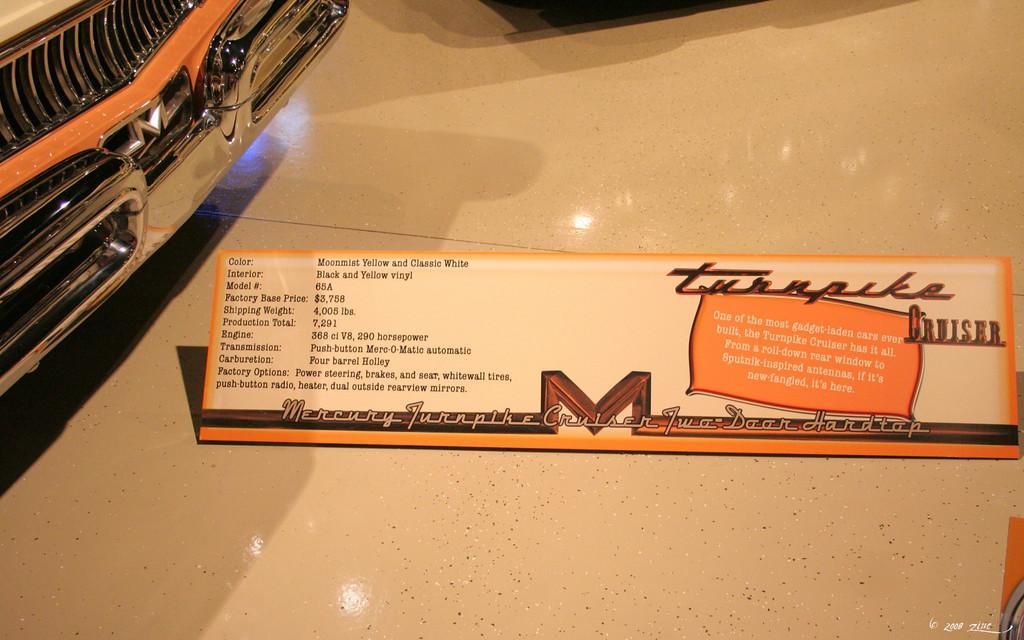Can you describe this image briefly? There is one board kept on the floor as we can see in the middle of this image. It seems like a car in the top left corner of this image. 